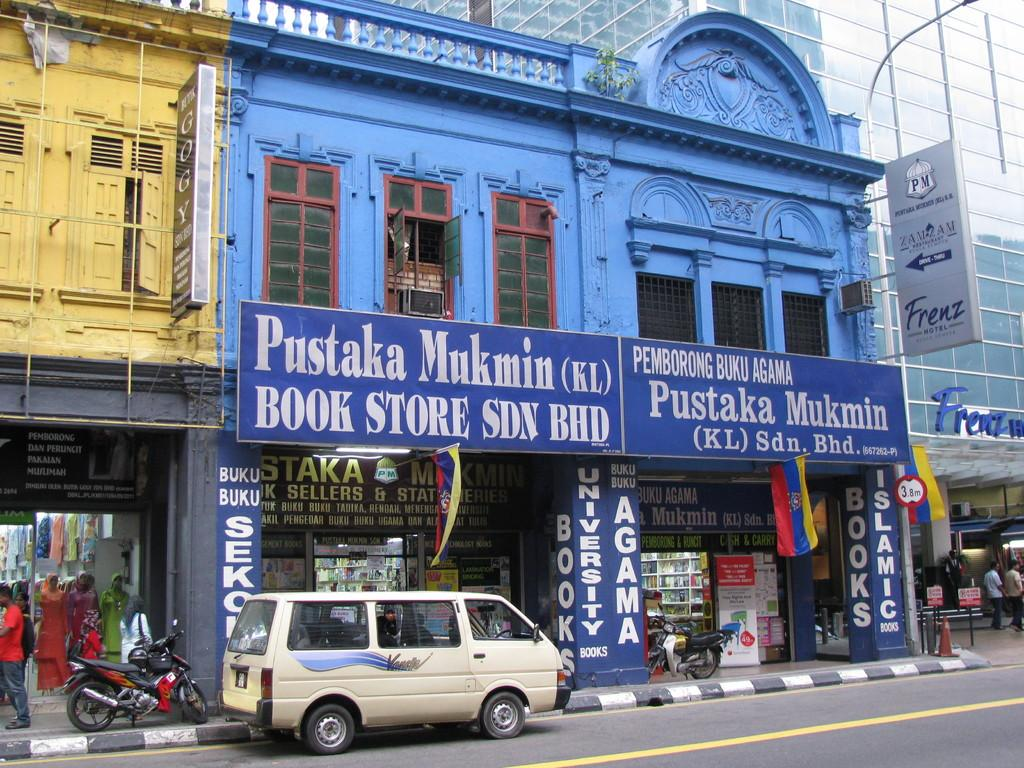<image>
Describe the image concisely. An off white van in front of a blue bookstore that says Pustaka Mukmin on it. 